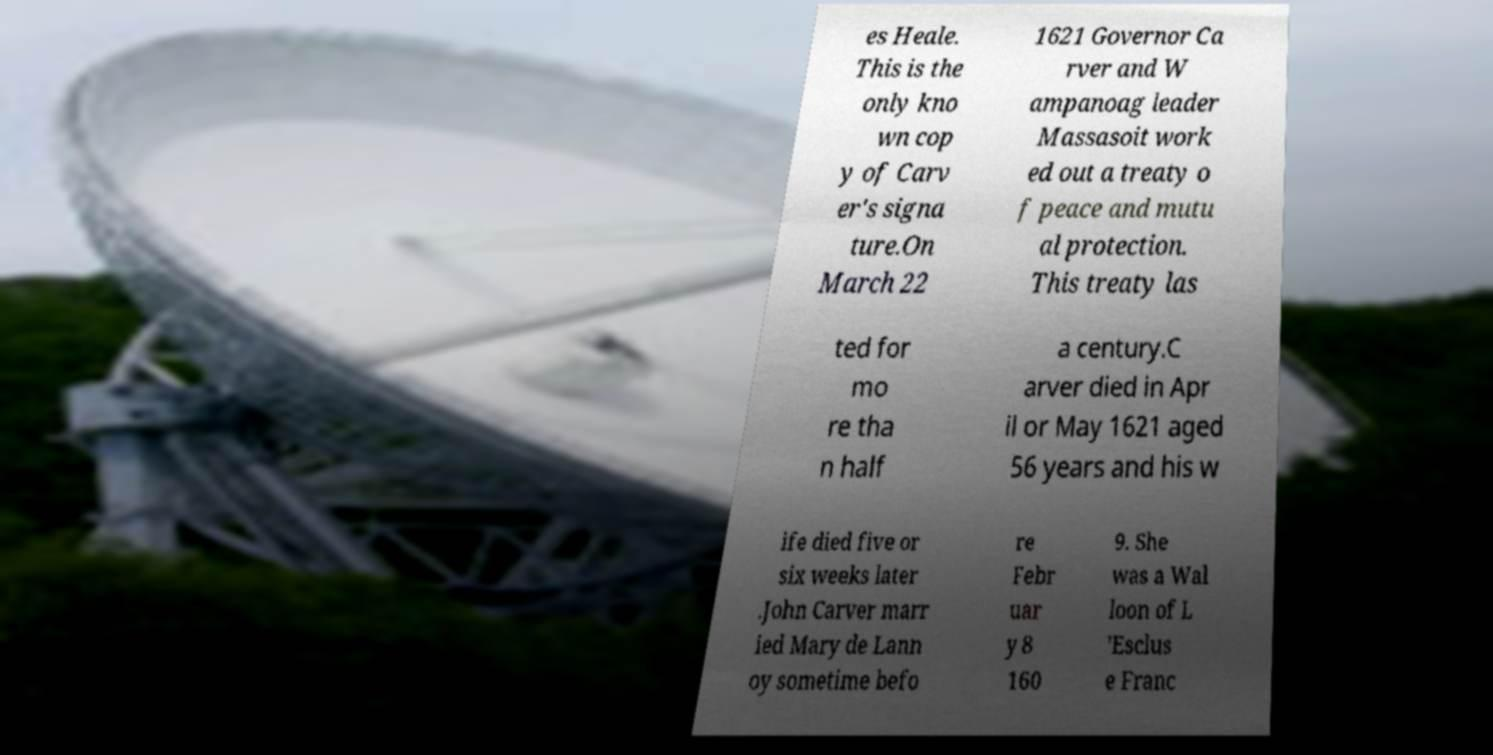Please identify and transcribe the text found in this image. es Heale. This is the only kno wn cop y of Carv er's signa ture.On March 22 1621 Governor Ca rver and W ampanoag leader Massasoit work ed out a treaty o f peace and mutu al protection. This treaty las ted for mo re tha n half a century.C arver died in Apr il or May 1621 aged 56 years and his w ife died five or six weeks later .John Carver marr ied Mary de Lann oy sometime befo re Febr uar y 8 160 9. She was a Wal loon of L ’Esclus e Franc 